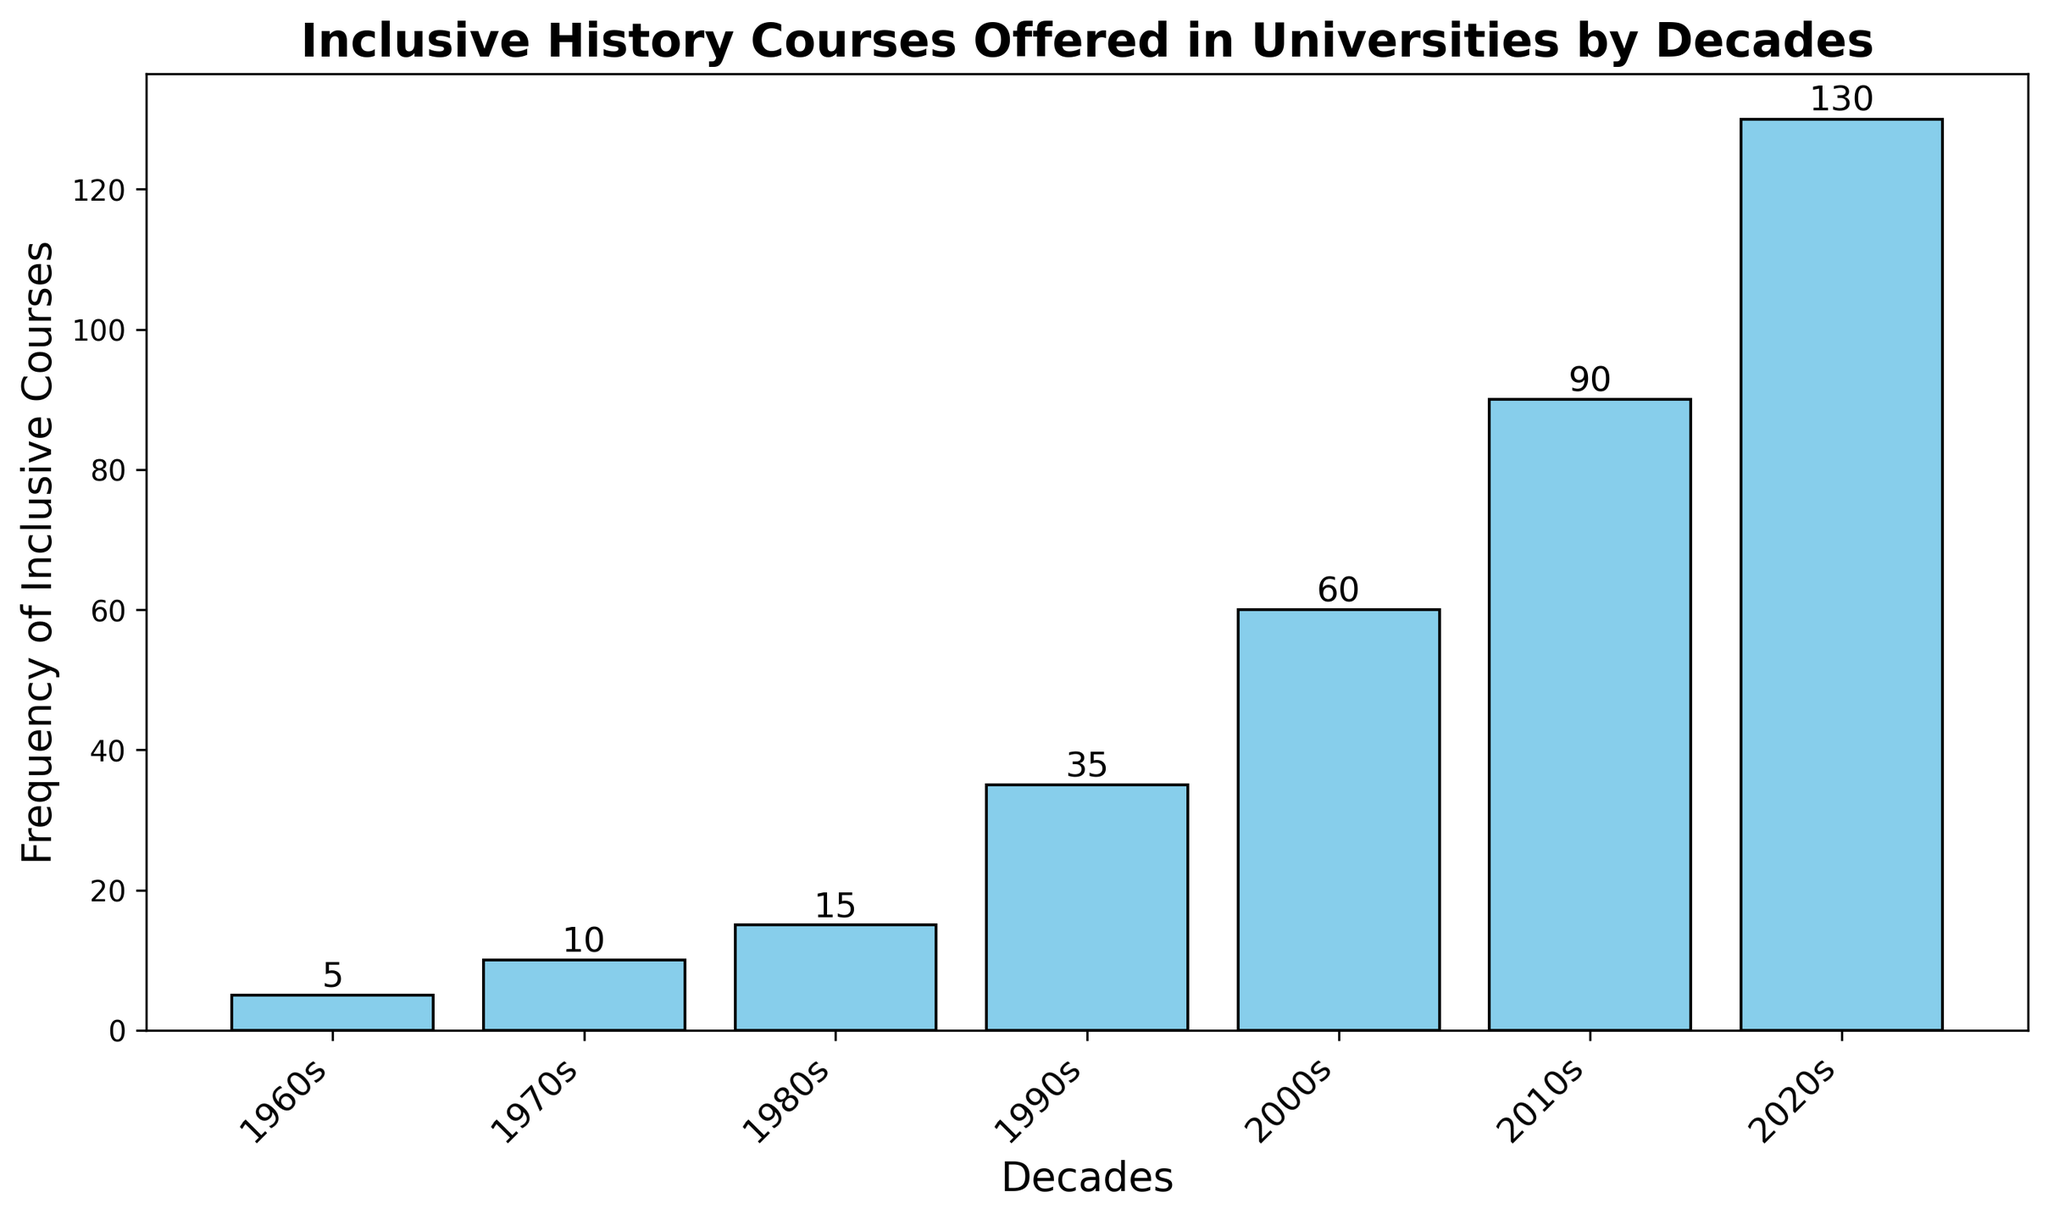What decade saw the greatest increase in the frequency of inclusive courses compared to the previous decade? By examining the differences between the frequencies in consecutive decades, we see that the largest increase is from 2010s (90) to 2020s (130), which is an increase of 40.
Answer: 2020s How many inclusive courses were introduced from the 1960s to the 1990s? Adding the frequencies of each decade from the 1960s to the 1990s: 5 (1960s) + 10 (1970s) + 15 (1980s) + 35 (1990s) = 65
Answer: 65 Which decade had exactly half the frequency of inclusive courses offered in the 2000s? The 2000s saw 60 courses; half of 60 is 30. We look to see if any decade matches this number, and none do. Thus, no decade had exactly half the frequency of the 2000s.
Answer: None Is the frequency of inclusive courses in the 1970s greater than in the 1960s? Checking the frequencies, the 1970s had 10 courses, while the 1960s had 5. Since 10 is greater than 5, the answer is yes.
Answer: Yes What's the sum of the frequencies of inclusive courses offered in the 2010s and 2020s? Adding the frequencies of the two decades: 90 (2010s) + 130 (2020s) = 220
Answer: 220 Which decade had the smallest number of inclusive courses offered? Comparing the frequencies across all decades, the 1960s had the smallest number of courses, which is 5.
Answer: 1960s How much more frequently were inclusive courses offered in the 1990s compared to the 1980s? Subtracting the frequency in the 1980s from that in the 1990s: 35 (1990s) - 15 (1980s) = 20
Answer: 20 What is the visual color representation of the bars in the plot? The categories bars in this plot are depicted in a sky-blue color. The edge of the bars is black.
Answer: Sky-blue Did the frequency of inclusive courses double at any point between decades? By examining the increases between decades, the frequency does not perfectly double between any two decades. Closest doubling: 2000s (60) to 2010s (90) which is not double.
Answer: No How much did the frequency increase from the 2000s to the 2010s? Subtracting the frequency in the 2000s from that in the 2010s: 90 (2010s) - 60 (2000s) = 30
Answer: 30 